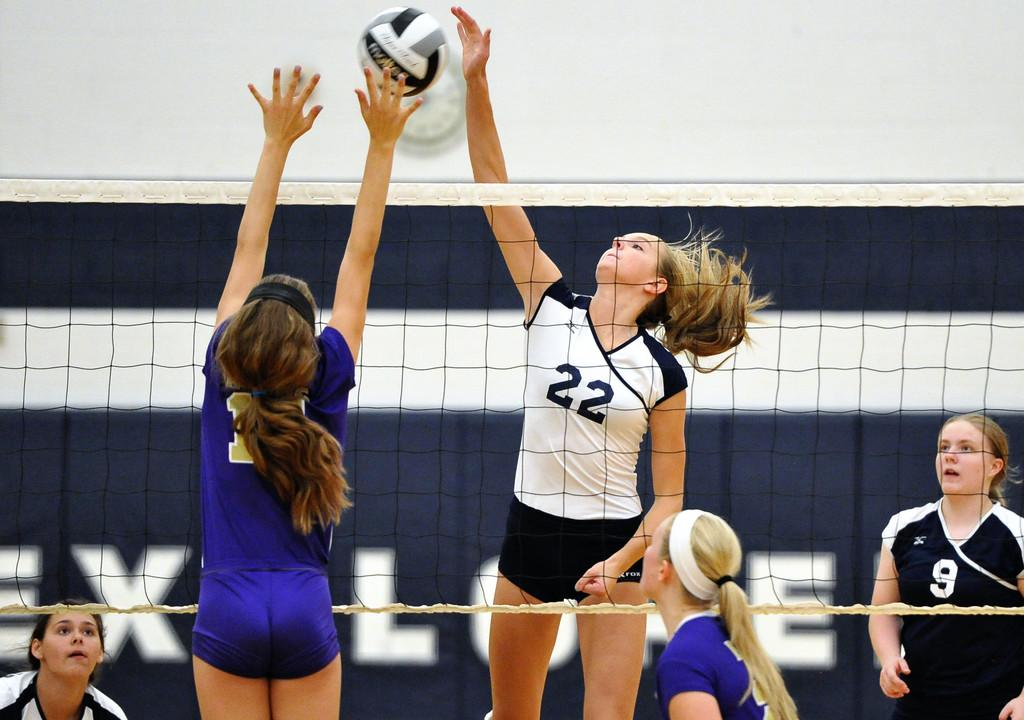<image>
Describe the image concisely. Girl wearing number 22 about to spike the volleyball. 